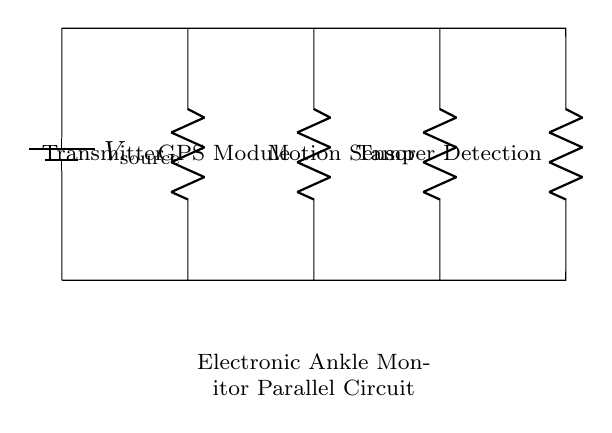What is the total number of components in the circuit? There are five components visible in the circuit: a transmitter, a GPS module, a motion sensor, and a tamper detection module, along with the voltage source.
Answer: five What does the voltage source power? The voltage source powers all the components connected in parallel: the transmitter, GPS module, motion sensor, and tamper detection.
Answer: all components What is the function of the GPS module? The GPS module is used to track the location of the wearer of the ankle monitor, indicating whether they remain within permitted areas or not.
Answer: location tracking How are the components connected in this circuit? The components are connected in parallel, meaning each one has its own connection to the voltage source, allowing them to operate independently.
Answer: in parallel What would happen if one component fails? If one component fails, the others still continue to function because of the parallel configuration, which allows for independent operation of each component.
Answer: others function Which component detects unauthorized tampering? The tamper detection module is responsible for identifying any unauthorized tampering with the ankle monitoring device.
Answer: tamper detection module If the voltage source is 5 volts, what is the voltage across each component? Each component receives the full voltage from the source when connected in parallel, so the voltage across each component is equal to the source voltage.
Answer: 5 volts 